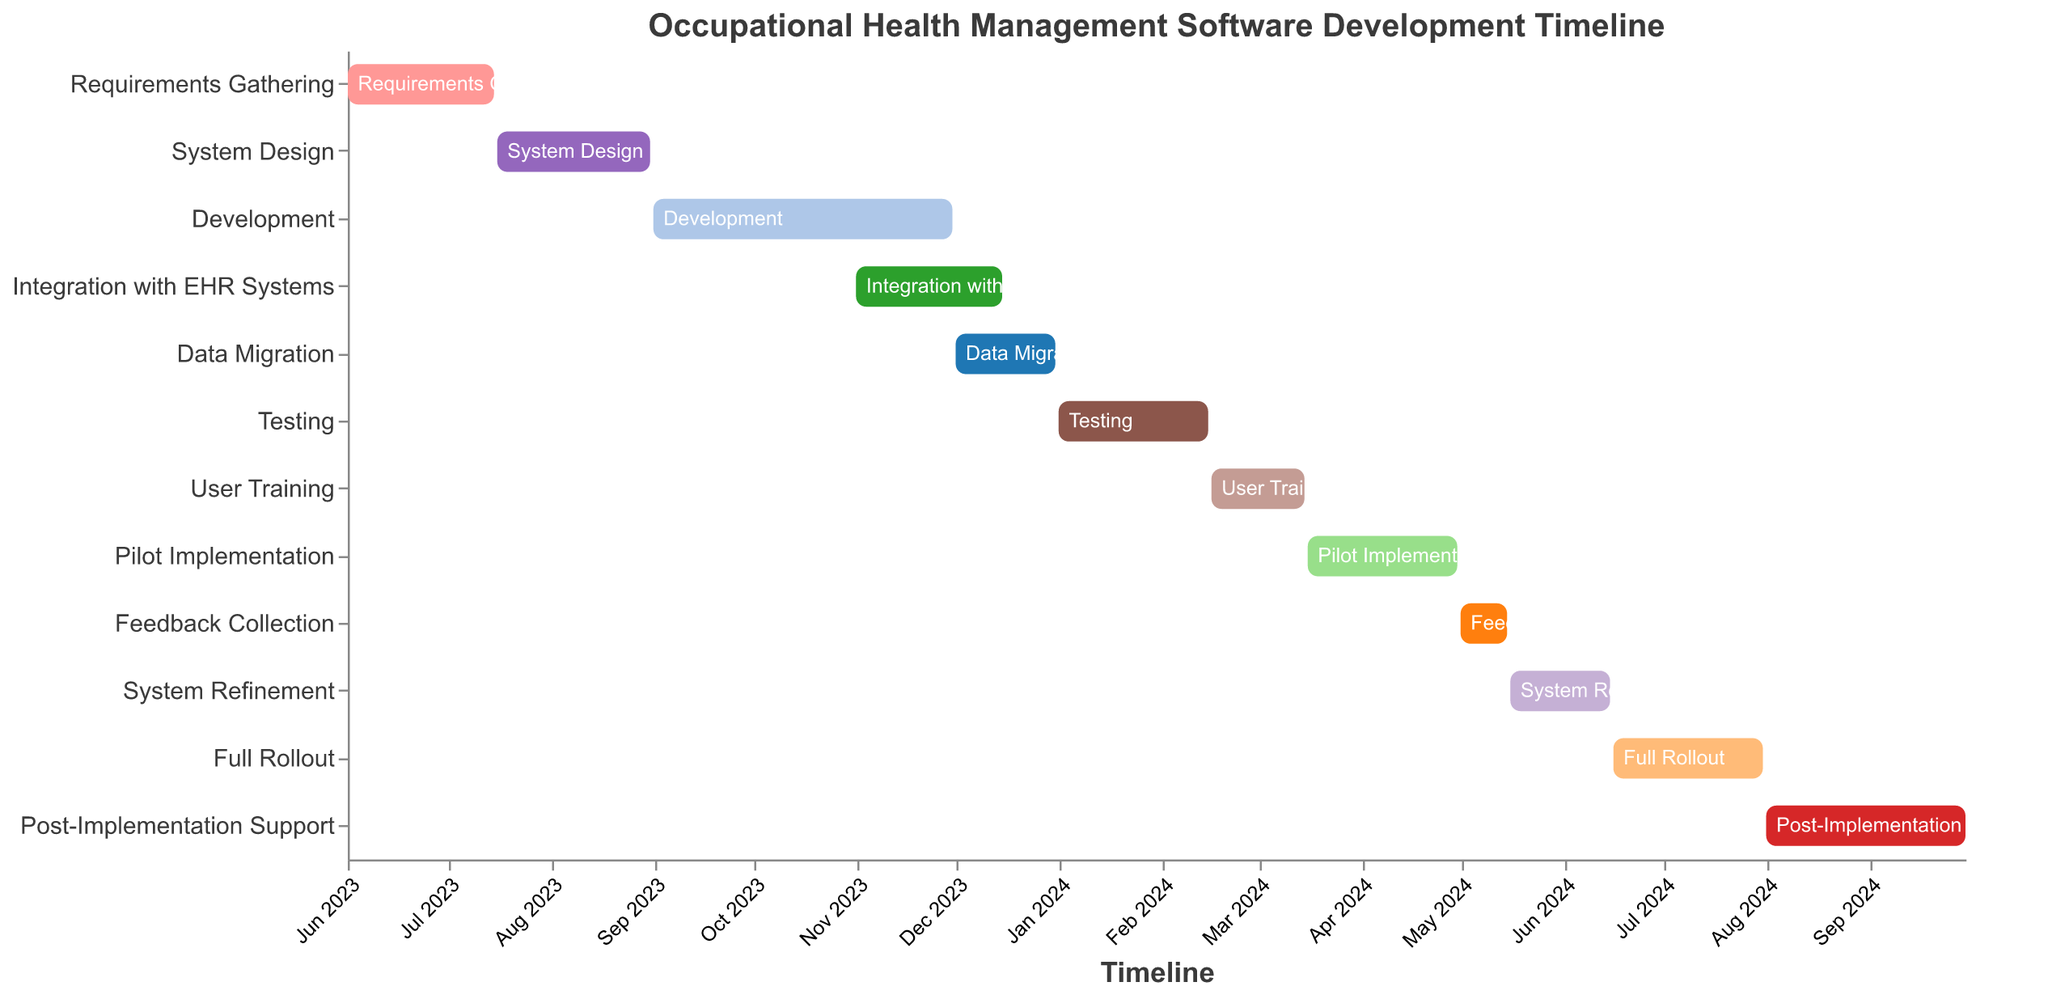What is the title of the chart? The title is located at the top of the chart and is displayed prominently in a larger font. The title conveys the overall purpose of the chart.
Answer: Occupational Health Management Software Development Timeline Which phase lasts the longest? To determine the longest phase, compare the durations of each task by looking at the Start and End dates. Calculate the durations for each task and identify the one with the maximum length.
Answer: Development How long does the Development phase last? Calculate the duration by subtracting the start date from the end date of the Development phase. The Development phase starts on 2023-09-01 and ends on 2023-11-30.
Answer: 3 months What are the start and end dates for User Training? Read the Start and End dates from the corresponding row for User Training.
Answer: 2024-02-16 to 2024-03-15 How many phases overlap with the Testing phase? Check which phases have start or end dates that fall within the duration of the Testing phase. The Testing phase runs from 2024-01-01 to 2024-02-15.
Answer: 1 Which phase directly follows System Design? Identify the end date of System Design and look for the phase that starts immediately after. System Design ends on 2023-08-31.
Answer: Development Is there any phase without overlap with others? Check if there is any phase where its start and end dates do not coincide with any other phase's start or end dates.
Answer: Full Rollout What is the total duration of the Pilot Implementation phase in weeks? Calculate the duration of the Pilot Implementation phase by subtracting the start date from the end date and then convert the result to weeks. The phase runs from 2024-03-16 to 2024-04-30.
Answer: 6 weeks Does Data Migration overlap with Integration with EHR Systems? If yes, by how many days? Compare the end date of Integration with EHR Systems with the start date of Data Migration to see if there is any overlap.
Answer: Yes, 15 days What phases occur simultaneously with Feedback Collection? Identify other phases with start or end dates that fall within the duration of the Feedback Collection phase, which runs from 2024-05-01 to 2024-05-15.
Answer: System Refinement 